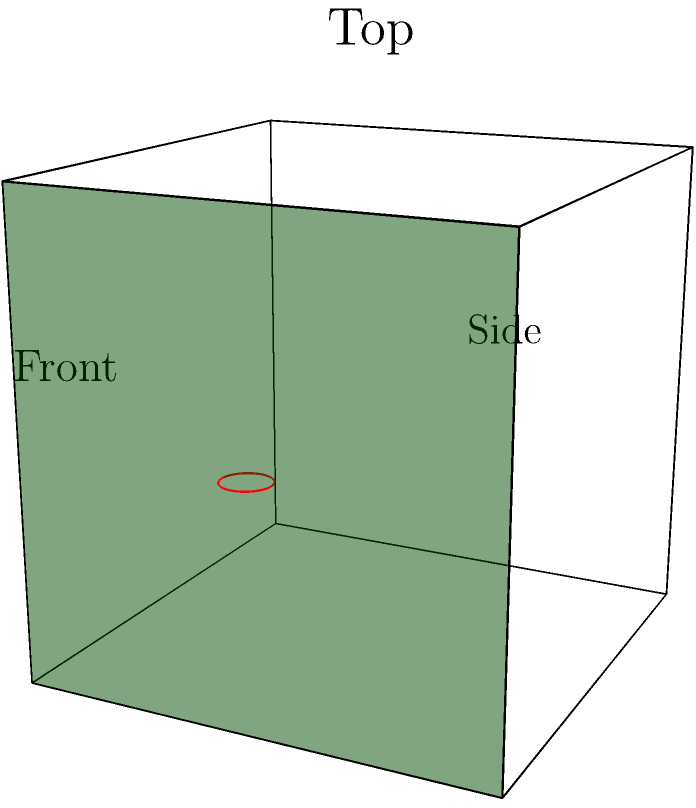As a tech-savvy entrepreneur exploring online banking, you're presented with a 3D model of a virtual bank vault for a security demonstration. Which of the following statements accurately describes the correct perspective view of the vault's door?

A) The door is on the left side when viewed from the front.
B) The door is on the right side when viewed from the front.
C) The door is on the top when viewed from above.
D) The door is on the bottom when viewed from above. To answer this question, let's analyze the 3D representation of the virtual bank vault:

1. First, identify the front view of the vault. In the given 3D model, the front view is facing us, with the label "Front" below it.

2. Observe the green semi-transparent surface in the model. This represents the door of the vault.

3. Notice that the door is located on the right side of the vault when viewed from the front.

4. The red circle on the green surface represents the handle of the vault door, confirming its position.

5. When viewed from above (top view), the door would be on the right side of the vault, not on the top or bottom.

6. The side view (labeled "Side") shows the depth of the vault, but the door is not visible from this perspective.

Based on this analysis, we can conclude that the correct statement is option B: The door is on the right side when viewed from the front.
Answer: B 